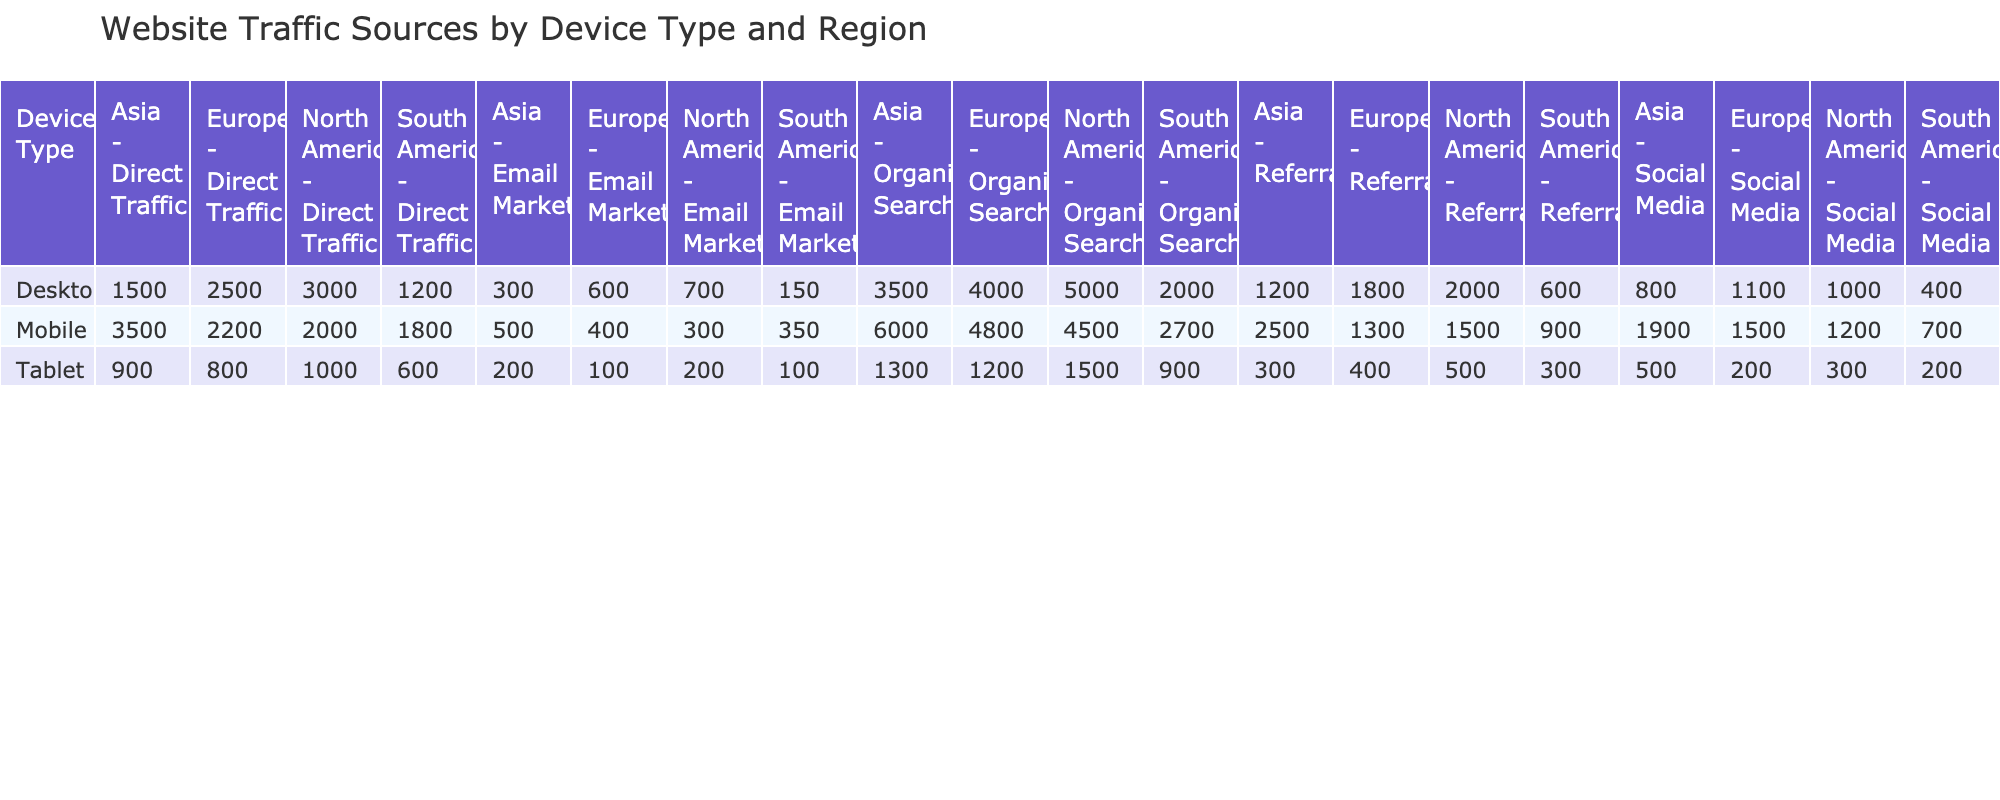What's the total Direct Traffic from Mobile devices in North America? In the table, we can find the value for Direct Traffic under the Mobile column for North America, which is 2000.
Answer: 2000 Which region has the highest number of Organic Search visits from Desktop users? In the table, we compare the Organic Search values for Desktop across all regions: North America (5000), Europe (4000), Asia (3500), South America (2000). North America has the highest number.
Answer: North America What is the sum of Email Marketing traffic across all device types in Asia? The Email Marketing values for Asia are: Desktop (300), Mobile (500), Tablet (200). Summing them gives 300 + 500 + 200 = 1000.
Answer: 1000 Is the number of Referrals from Desktop users in Europe higher than that from Mobile users in Europe? Referrals from Desktop in Europe is 1800, while from Mobile in Europe it is 1300. Since 1800 > 1300, we conclude that the statement is true.
Answer: Yes What percentage of the total traffic from Mobile devices in North America is generated by Social Media? Mobile traffic in North America has a total of Direct Traffic (2000) + Organic Search (4500) + Referrals (1500) + Social Media (1200) + Email Marketing (300) = 10500. The Social Media value is 1200. Thus, (1200 / 10500) * 100 = 11.43%.
Answer: 11.43% What is the difference in Direct Traffic between Mobile users in Asia and Desktop users in Europe? Direct Traffic for Mobile users in Asia is 3500 and for Desktop users in Europe is 2500. So, the difference is 3500 - 2500 = 1000.
Answer: 1000 Does the total traffic from Tablet devices in South America exceed the total traffic from Mobile devices in South America? Total traffic from Tablet in South America is (600 + 900 + 300 + 200 + 100) = 2100, whereas for Mobile it is (1800 + 2700 + 900 + 700 + 350) = 6550. Since 2100 < 6550, the statement is false.
Answer: No What is the average number of Organic Search visits across all device types in Europe? Organic Search visits in Europe are: Desktop (4000), Mobile (4800), Tablet (1200). The total is 4000 + 4800 + 1200 = 10000. The average is 10000 / 3 = 3333.33.
Answer: 3333.33 Which device type in Asia has the highest traffic from Social Media? The Social Media values for Asia are: Desktop (800), Mobile (1900), Tablet (500). Comparing these, Mobile has the highest at 1900.
Answer: Mobile 